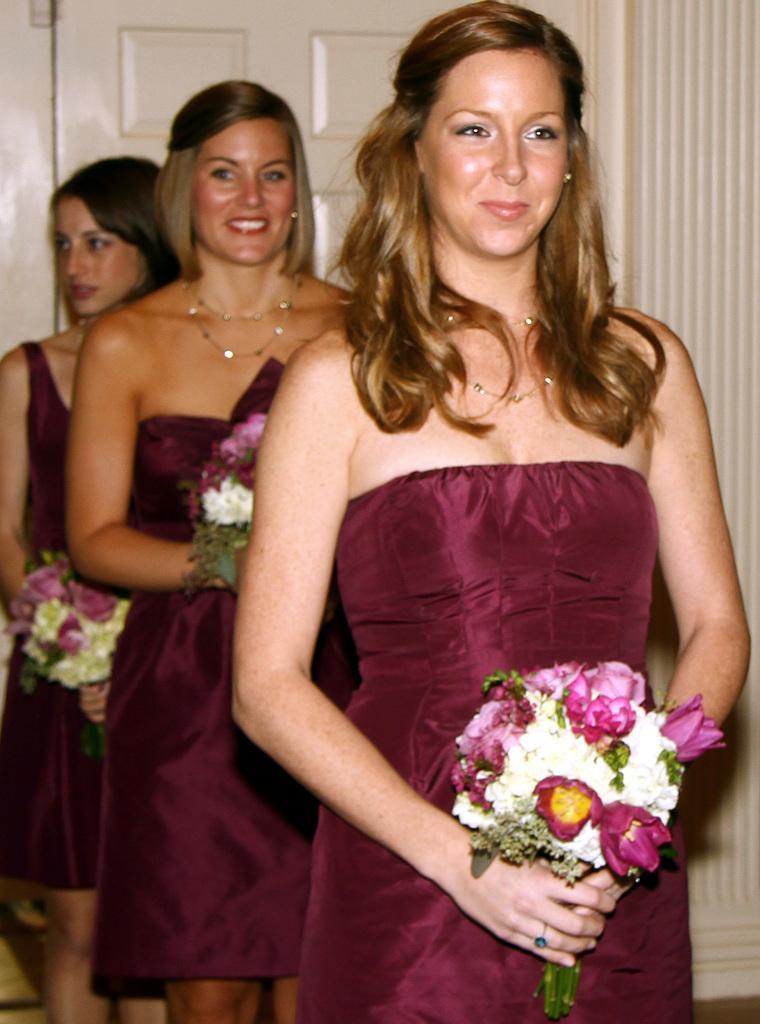Describe this image in one or two sentences. In the center of the image we can see ladies standing and holding bouquets in their hands. In the background there is a door. 